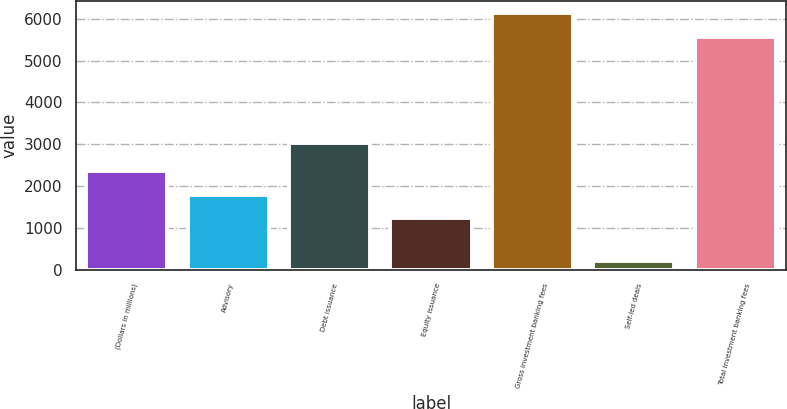Convert chart. <chart><loc_0><loc_0><loc_500><loc_500><bar_chart><fcel>(Dollars in millions)<fcel>Advisory<fcel>Debt issuance<fcel>Equity issuance<fcel>Gross investment banking fees<fcel>Self-led deals<fcel>Total investment banking fees<nl><fcel>2350.4<fcel>1793.2<fcel>3033<fcel>1236<fcel>6129.2<fcel>200<fcel>5572<nl></chart> 